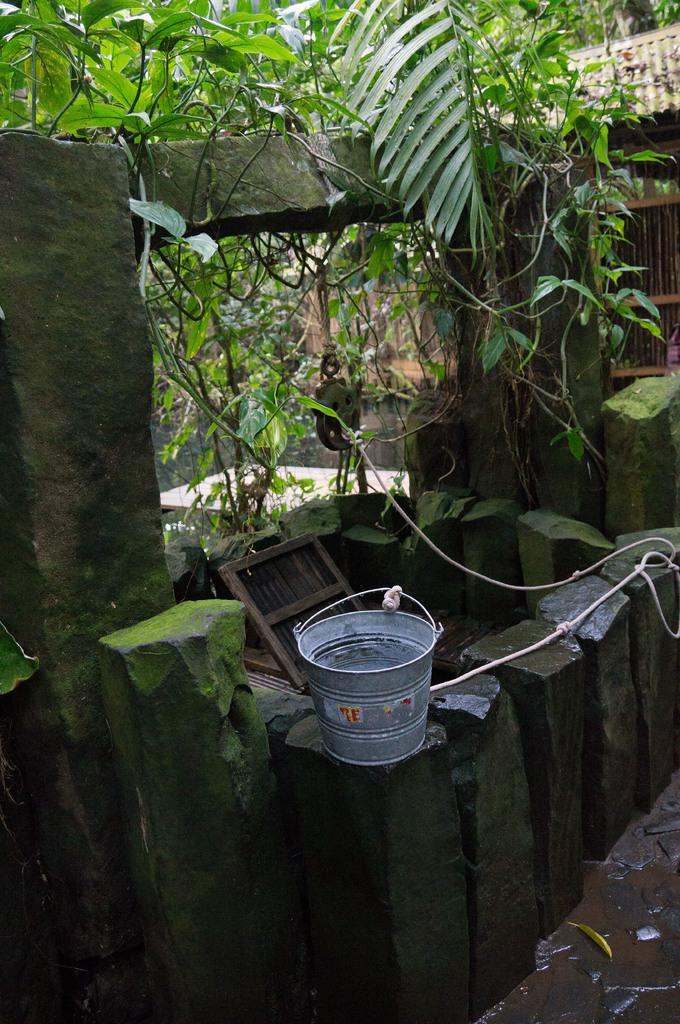What type of structure is built with rocks in the image? There is a well in the image, built with rocks. What is attached to the rope in the well? A bucket is tied to the rope in the well. What type of vegetation can be seen in the image? There are trees visible in the image. What type of building is present in the image? There is a house in the image. How does the well generate profit in the image? The well does not generate profit in the image; it is a structure for accessing water. What type of relation can be seen between the trees and the well in the image? There is no specific relation between the trees and the well in the image; they are simply two separate elements in the scene. 